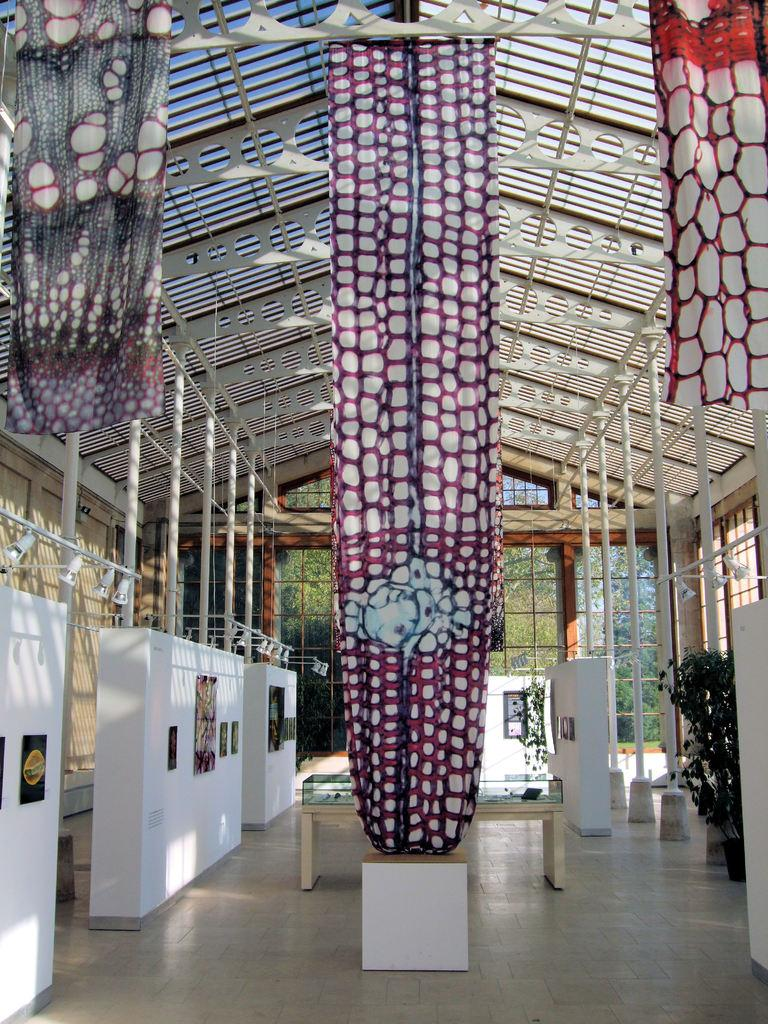What type of window covering is visible in the image? There are colorful curtains in the image. What type of furniture is present in the image? There is a table in the image. What type of structure is present in the image? There are poles in the image. What type of illumination is present in the image? There are lights in the image. What type of decorative items are present in the image? There are frames in the image. What type of natural elements are present in the image? There are trees in the image. What type of container for plants is present in the image? There is a flower pot in the image. What type of transparent barriers are present in the image? There are glass windows in the image. What type of small storage building is present in the image? There is a shed in the image. What type of straw is being used for the protest in the image? There is no protest or straw present in the image. What type of brick is being used to build the shed in the image? The shed in the image is already built, and there is no mention of bricks being used in its construction. 